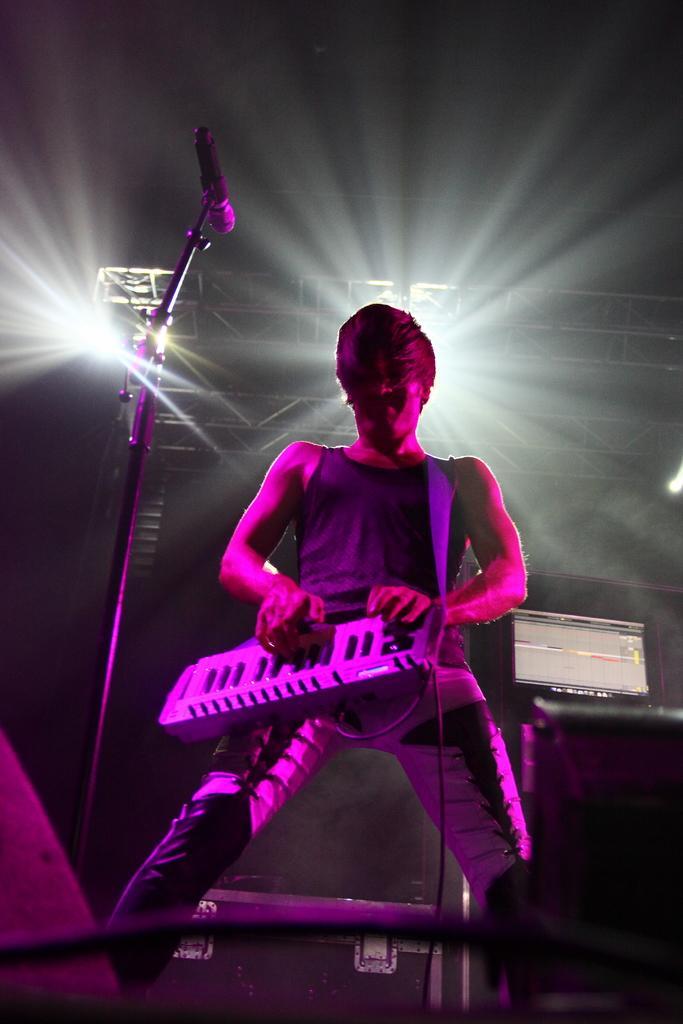In one or two sentences, can you explain what this image depicts? In this picture I can see in the middle a man is playing the piano. On the left side there is a microphone, in the background there are lights. 